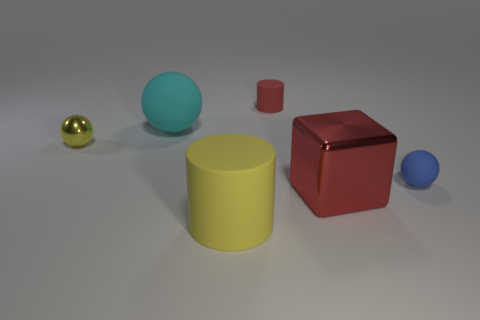Are there any objects left of the matte cylinder behind the big rubber object that is behind the red block?
Offer a very short reply. Yes. There is a red metal thing that is the same size as the cyan object; what is its shape?
Your response must be concise. Cube. Are there any matte cylinders of the same color as the large block?
Your answer should be compact. Yes. Do the large yellow object and the cyan object have the same shape?
Ensure brevity in your answer.  No. How many tiny objects are matte cylinders or rubber things?
Ensure brevity in your answer.  2. There is another big sphere that is made of the same material as the blue ball; what color is it?
Make the answer very short. Cyan. How many blue things are made of the same material as the big red object?
Your answer should be compact. 0. There is a ball that is to the right of the big yellow thing; is it the same size as the yellow object that is behind the small blue ball?
Offer a terse response. Yes. What material is the yellow object that is on the right side of the big cyan rubber thing behind the tiny yellow ball made of?
Make the answer very short. Rubber. Are there fewer tiny yellow balls that are in front of the yellow metallic thing than large yellow rubber cylinders that are behind the red block?
Give a very brief answer. No. 